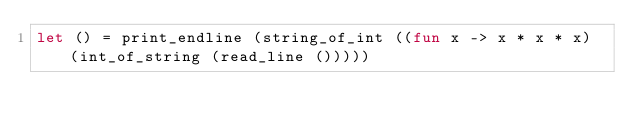Convert code to text. <code><loc_0><loc_0><loc_500><loc_500><_OCaml_>let () = print_endline (string_of_int ((fun x -> x * x * x) (int_of_string (read_line ()))))</code> 